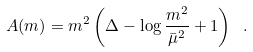Convert formula to latex. <formula><loc_0><loc_0><loc_500><loc_500>A ( m ) = m ^ { 2 } \left ( \Delta - \log \frac { m ^ { 2 } } { \bar { \mu } ^ { 2 } } + 1 \right ) \ .</formula> 